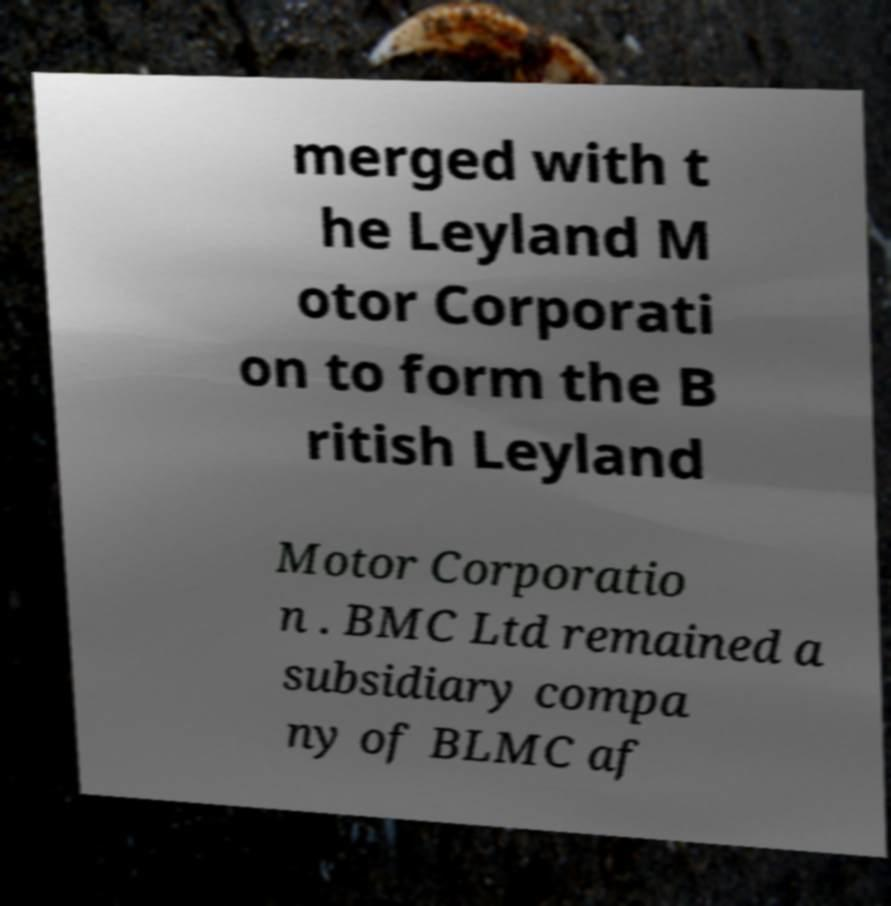There's text embedded in this image that I need extracted. Can you transcribe it verbatim? merged with t he Leyland M otor Corporati on to form the B ritish Leyland Motor Corporatio n . BMC Ltd remained a subsidiary compa ny of BLMC af 